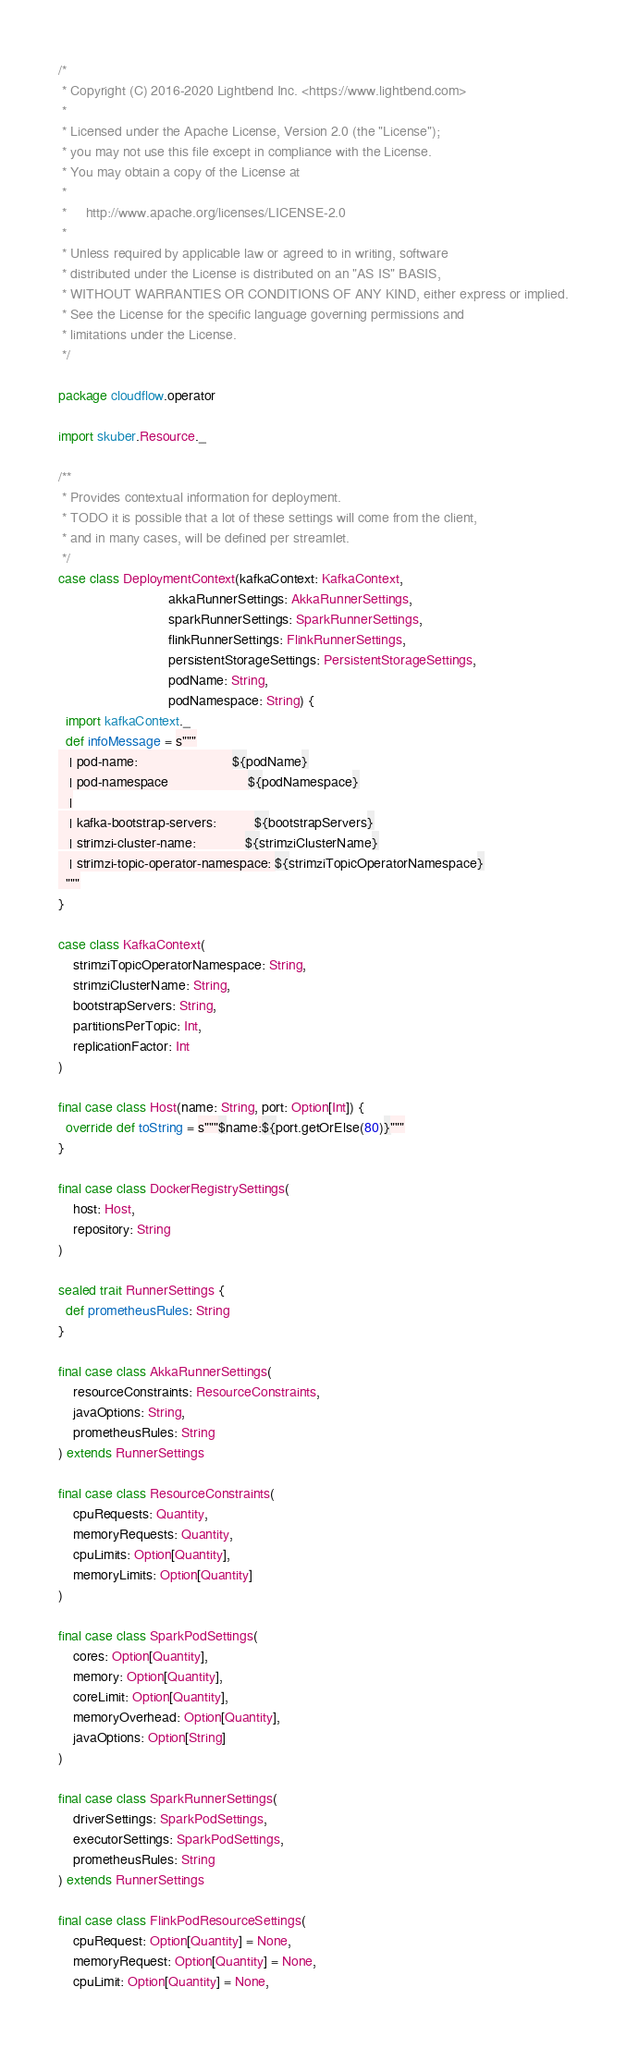Convert code to text. <code><loc_0><loc_0><loc_500><loc_500><_Scala_>/*
 * Copyright (C) 2016-2020 Lightbend Inc. <https://www.lightbend.com>
 *
 * Licensed under the Apache License, Version 2.0 (the "License");
 * you may not use this file except in compliance with the License.
 * You may obtain a copy of the License at
 *
 *     http://www.apache.org/licenses/LICENSE-2.0
 *
 * Unless required by applicable law or agreed to in writing, software
 * distributed under the License is distributed on an "AS IS" BASIS,
 * WITHOUT WARRANTIES OR CONDITIONS OF ANY KIND, either express or implied.
 * See the License for the specific language governing permissions and
 * limitations under the License.
 */

package cloudflow.operator

import skuber.Resource._

/**
 * Provides contextual information for deployment.
 * TODO it is possible that a lot of these settings will come from the client,
 * and in many cases, will be defined per streamlet.
 */
case class DeploymentContext(kafkaContext: KafkaContext,
                             akkaRunnerSettings: AkkaRunnerSettings,
                             sparkRunnerSettings: SparkRunnerSettings,
                             flinkRunnerSettings: FlinkRunnerSettings,
                             persistentStorageSettings: PersistentStorageSettings,
                             podName: String,
                             podNamespace: String) {
  import kafkaContext._
  def infoMessage = s"""
   | pod-name:                         ${podName}
   | pod-namespace                     ${podNamespace}
   |
   | kafka-bootstrap-servers:          ${bootstrapServers}
   | strimzi-cluster-name:             ${strimziClusterName}
   | strimzi-topic-operator-namespace: ${strimziTopicOperatorNamespace}
  """
}

case class KafkaContext(
    strimziTopicOperatorNamespace: String,
    strimziClusterName: String,
    bootstrapServers: String,
    partitionsPerTopic: Int,
    replicationFactor: Int
)

final case class Host(name: String, port: Option[Int]) {
  override def toString = s"""$name:${port.getOrElse(80)}"""
}

final case class DockerRegistrySettings(
    host: Host,
    repository: String
)

sealed trait RunnerSettings {
  def prometheusRules: String
}

final case class AkkaRunnerSettings(
    resourceConstraints: ResourceConstraints,
    javaOptions: String,
    prometheusRules: String
) extends RunnerSettings

final case class ResourceConstraints(
    cpuRequests: Quantity,
    memoryRequests: Quantity,
    cpuLimits: Option[Quantity],
    memoryLimits: Option[Quantity]
)

final case class SparkPodSettings(
    cores: Option[Quantity],
    memory: Option[Quantity],
    coreLimit: Option[Quantity],
    memoryOverhead: Option[Quantity],
    javaOptions: Option[String]
)

final case class SparkRunnerSettings(
    driverSettings: SparkPodSettings,
    executorSettings: SparkPodSettings,
    prometheusRules: String
) extends RunnerSettings

final case class FlinkPodResourceSettings(
    cpuRequest: Option[Quantity] = None,
    memoryRequest: Option[Quantity] = None,
    cpuLimit: Option[Quantity] = None,</code> 